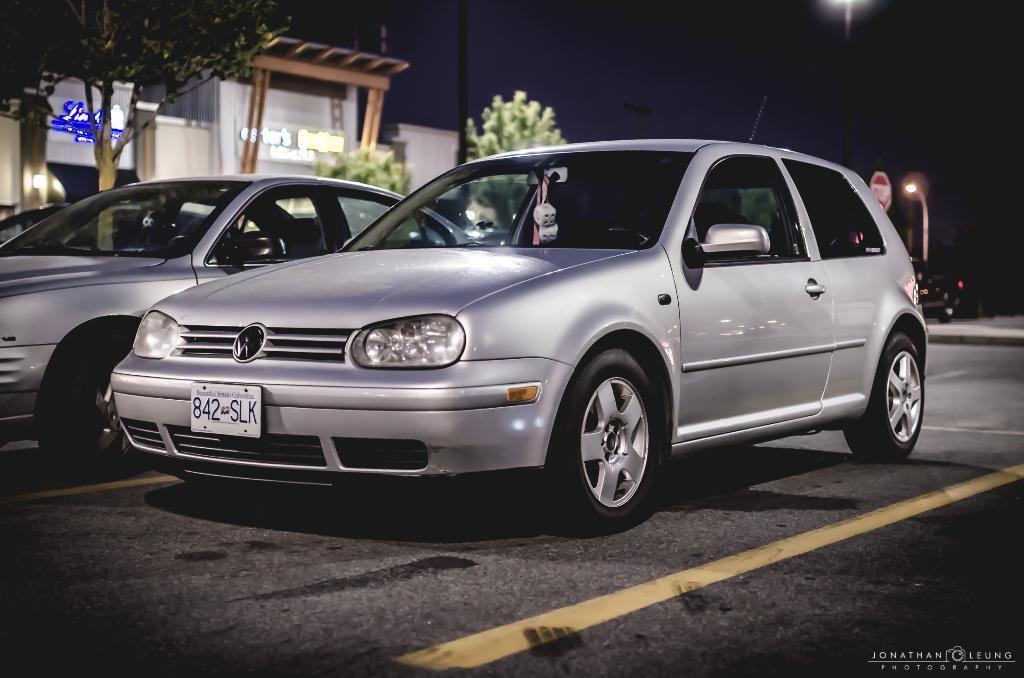How would you summarize this image in a sentence or two? Vehicles are on the road. Background it is blur. We can see a buildings, tree, signboard and light pole. 